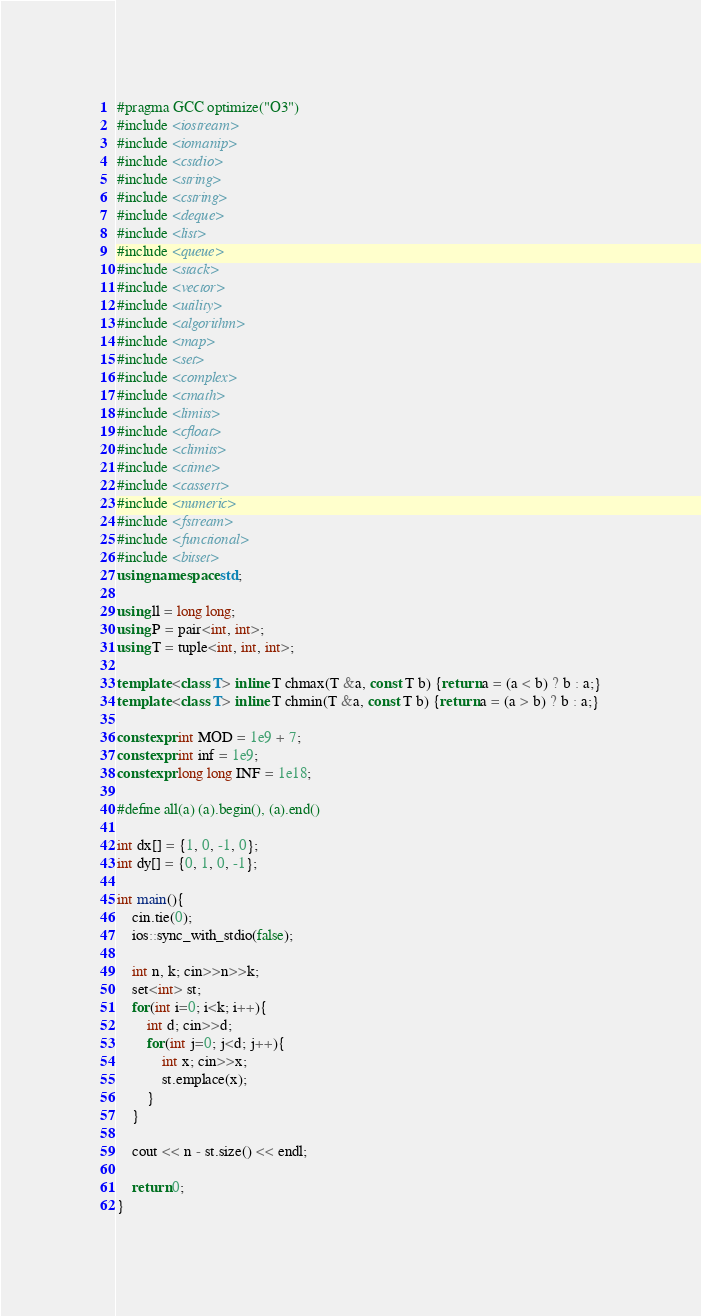Convert code to text. <code><loc_0><loc_0><loc_500><loc_500><_C++_>#pragma GCC optimize("O3")
#include <iostream>
#include <iomanip>
#include <cstdio>
#include <string>
#include <cstring>
#include <deque>
#include <list>
#include <queue>
#include <stack>
#include <vector>
#include <utility>
#include <algorithm>
#include <map>
#include <set>
#include <complex>
#include <cmath>
#include <limits>
#include <cfloat>
#include <climits>
#include <ctime>
#include <cassert>
#include <numeric>
#include <fstream>
#include <functional>
#include <bitset>
using namespace std;

using ll = long long;
using P = pair<int, int>;
using T = tuple<int, int, int>;

template <class T> inline T chmax(T &a, const T b) {return a = (a < b) ? b : a;}
template <class T> inline T chmin(T &a, const T b) {return a = (a > b) ? b : a;}

constexpr int MOD = 1e9 + 7;
constexpr int inf = 1e9;
constexpr long long INF = 1e18;

#define all(a) (a).begin(), (a).end()

int dx[] = {1, 0, -1, 0};
int dy[] = {0, 1, 0, -1};

int main(){
    cin.tie(0);
    ios::sync_with_stdio(false);

    int n, k; cin>>n>>k;
    set<int> st;
    for(int i=0; i<k; i++){
        int d; cin>>d;
        for(int j=0; j<d; j++){
            int x; cin>>x;
            st.emplace(x);
        }
    }

    cout << n - st.size() << endl;

    return 0;
}</code> 